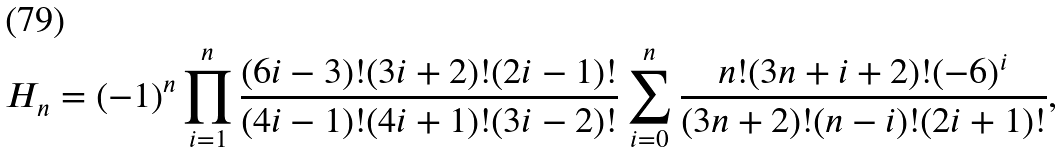Convert formula to latex. <formula><loc_0><loc_0><loc_500><loc_500>H _ { n } = ( - 1 ) ^ { n } \prod _ { i = 1 } ^ { n } \frac { ( 6 i - 3 ) ! ( 3 i + 2 ) ! ( 2 i - 1 ) ! } { ( 4 i - 1 ) ! ( 4 i + 1 ) ! ( 3 i - 2 ) ! } \sum _ { i = 0 } ^ { n } \frac { n ! ( 3 n + i + 2 ) ! ( - 6 ) ^ { i } } { ( 3 n + 2 ) ! ( n - i ) ! ( 2 i + 1 ) ! } ,</formula> 